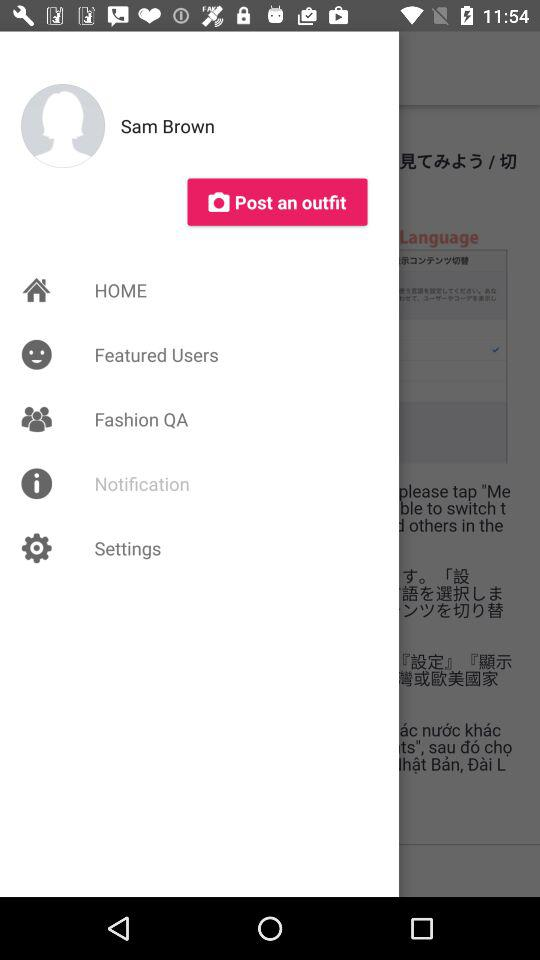What is the name of the user? The name of the user is Sam Brown. 